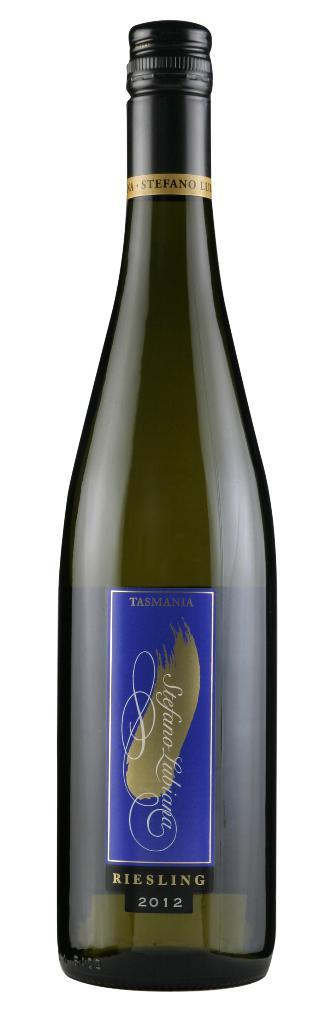<image>
Share a concise interpretation of the image provided. A bottle of Riesling from 2012 is against a white backdrop. 